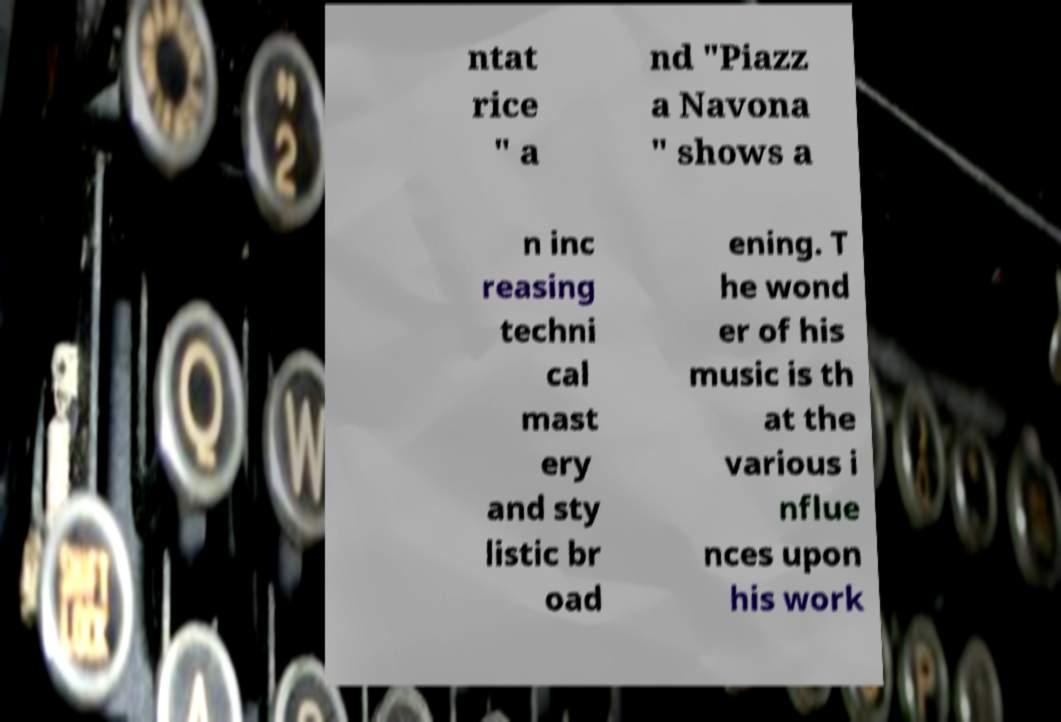There's text embedded in this image that I need extracted. Can you transcribe it verbatim? ntat rice " a nd "Piazz a Navona " shows a n inc reasing techni cal mast ery and sty listic br oad ening. T he wond er of his music is th at the various i nflue nces upon his work 